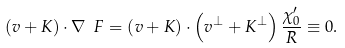<formula> <loc_0><loc_0><loc_500><loc_500>\left ( v + K \right ) \cdot \nabla \ F = \left ( v + K \right ) \cdot \left ( v ^ { \bot } + K ^ { \bot } \right ) \frac { \chi _ { 0 } ^ { \prime } } { R } \equiv 0 .</formula> 